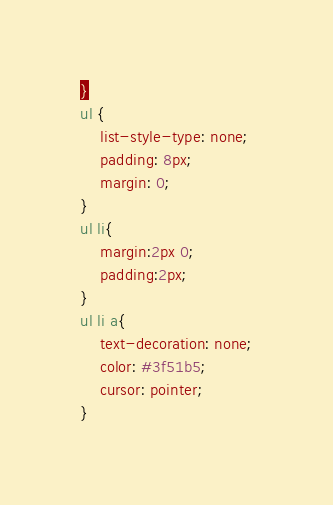Convert code to text. <code><loc_0><loc_0><loc_500><loc_500><_CSS_>}
ul {
    list-style-type: none;
    padding: 8px;
    margin: 0;
}
ul li{
    margin:2px 0;
    padding:2px;
}
ul li a{
    text-decoration: none;
    color: #3f51b5;
    cursor: pointer;
}</code> 